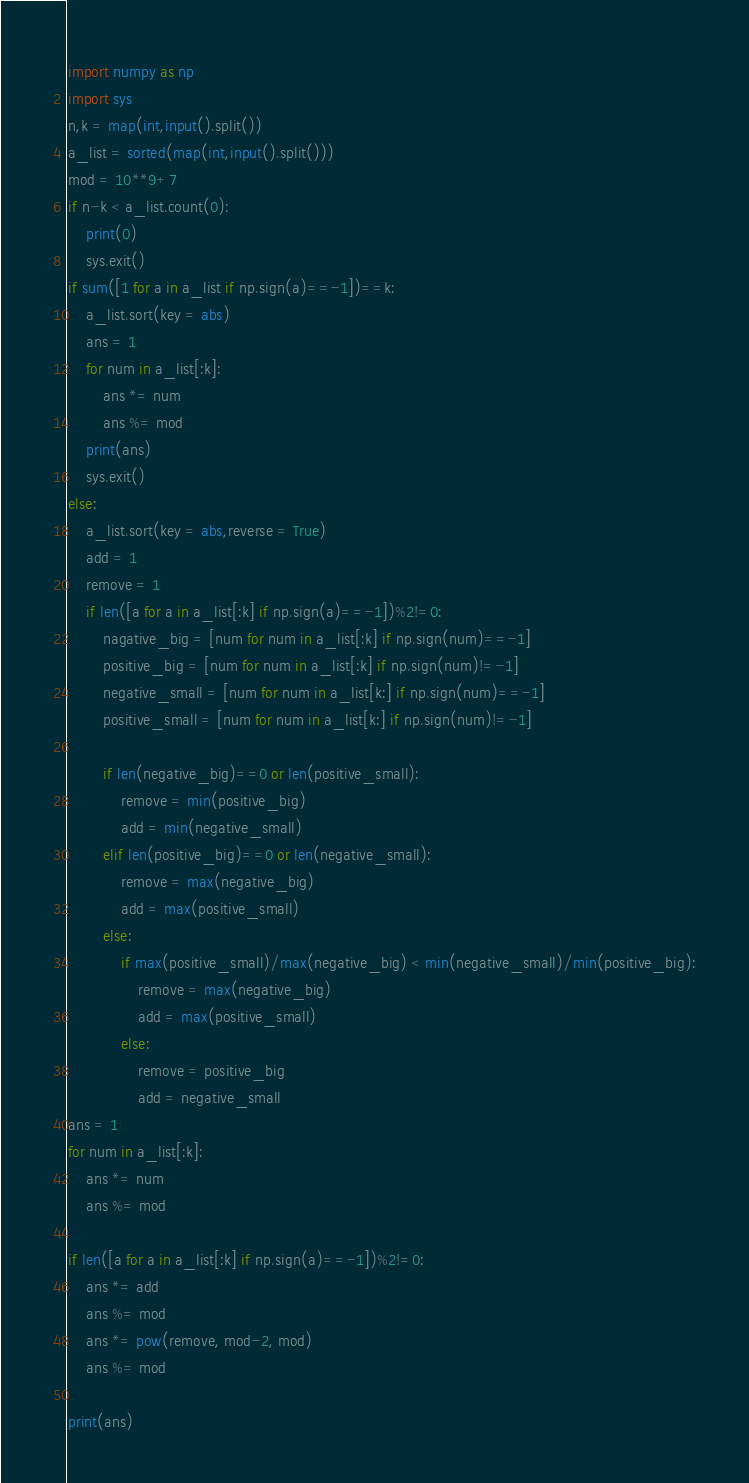Convert code to text. <code><loc_0><loc_0><loc_500><loc_500><_Python_>import numpy as np
import sys
n,k = map(int,input().split())
a_list = sorted(map(int,input().split()))
mod = 10**9+7
if n-k < a_list.count(0):
    print(0)
    sys.exit()
if sum([1 for a in a_list if np.sign(a)==-1])==k:
    a_list.sort(key = abs)
    ans = 1
    for num in a_list[:k]:
        ans *= num
        ans %= mod
    print(ans)
    sys.exit()
else:
    a_list.sort(key = abs,reverse = True)
    add = 1
    remove = 1
    if len([a for a in a_list[:k] if np.sign(a)==-1])%2!=0:
        nagative_big = [num for num in a_list[:k] if np.sign(num)==-1]
        positive_big = [num for num in a_list[:k] if np.sign(num)!=-1]
        negative_small = [num for num in a_list[k:] if np.sign(num)==-1]
        positive_small = [num for num in a_list[k:] if np.sign(num)!=-1]
        
        if len(negative_big)==0 or len(positive_small):
            remove = min(positive_big)
            add = min(negative_small)
        elif len(positive_big)==0 or len(negative_small):
            remove = max(negative_big)
            add = max(positive_small)
        else:
            if max(positive_small)/max(negative_big) < min(negative_small)/min(positive_big):
                remove = max(negative_big)
                add = max(positive_small)
            else:
                remove = positive_big
                add = negative_small
ans = 1
for num in a_list[:k]:
    ans *= num
    ans %= mod
    
if len([a for a in a_list[:k] if np.sign(a)==-1])%2!=0:
    ans *= add
    ans %= mod
    ans *= pow(remove, mod-2, mod)
    ans %= mod

print(ans)</code> 